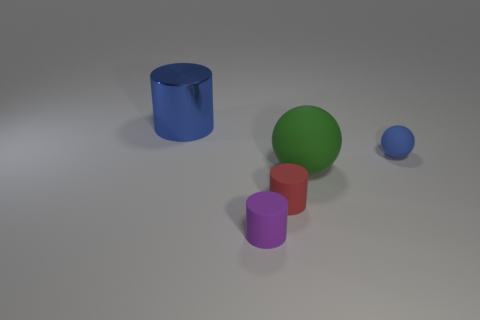Is there a blue metal block of the same size as the purple thing?
Give a very brief answer. No. Is the shape of the large thing that is in front of the small blue matte sphere the same as  the blue matte thing?
Provide a short and direct response. Yes. Is the small blue matte thing the same shape as the small red thing?
Keep it short and to the point. No. Are there any other tiny purple rubber things that have the same shape as the purple rubber thing?
Provide a succinct answer. No. There is a big object in front of the blue object that is left of the blue matte object; what shape is it?
Your answer should be compact. Sphere. What color is the large thing in front of the blue shiny thing?
Give a very brief answer. Green. The purple thing that is the same material as the tiny red thing is what size?
Ensure brevity in your answer.  Small. There is a metal object that is the same shape as the red matte object; what is its size?
Your answer should be compact. Large. Is there a green ball?
Provide a short and direct response. Yes. What number of objects are big things that are on the right side of the big blue metal thing or green spheres?
Ensure brevity in your answer.  1. 